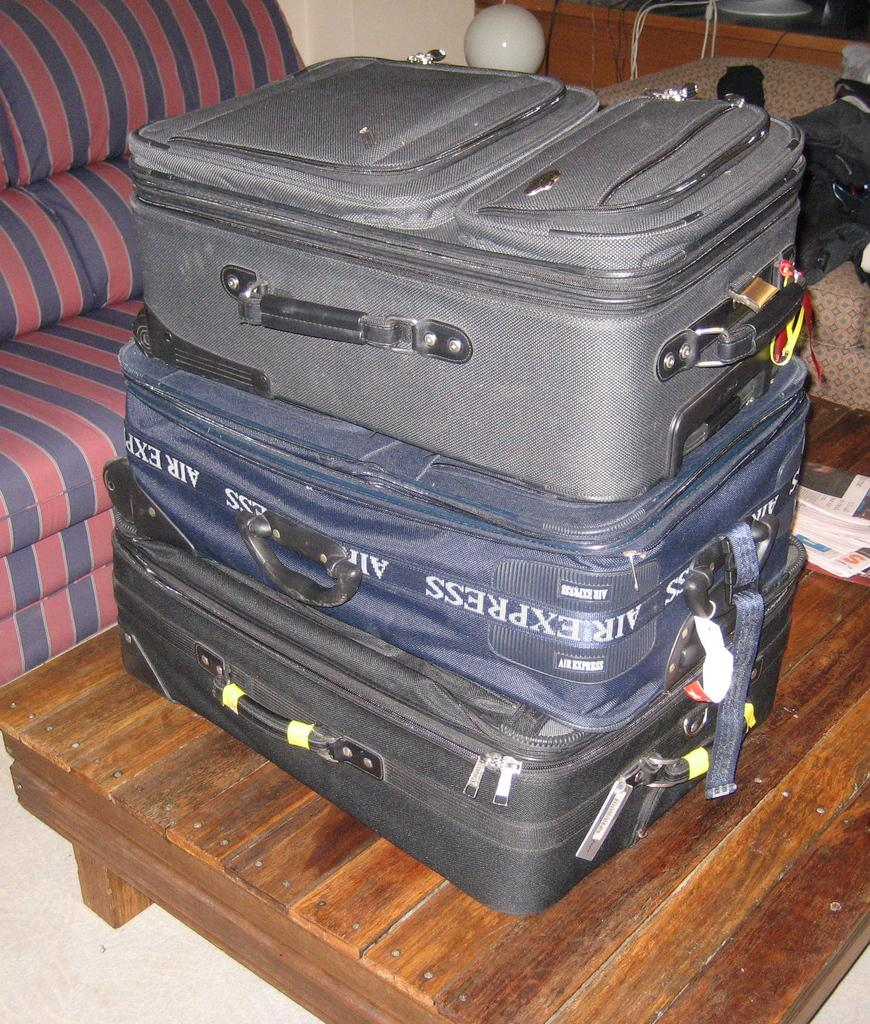How many suitcases are visible in the image? There are 3 suitcases in the image. Where are the suitcases located? The suitcases are on a table. What can be seen in the background of the image? There is a couch and a wall in the background of the image. Are there any jellyfish visible in the image? No, there are no jellyfish present in the image. What type of animals might be found at a zoo that are not visible in the image? It is impossible to determine which animals might be found at a zoo based on the image, as it does not contain any animals. 